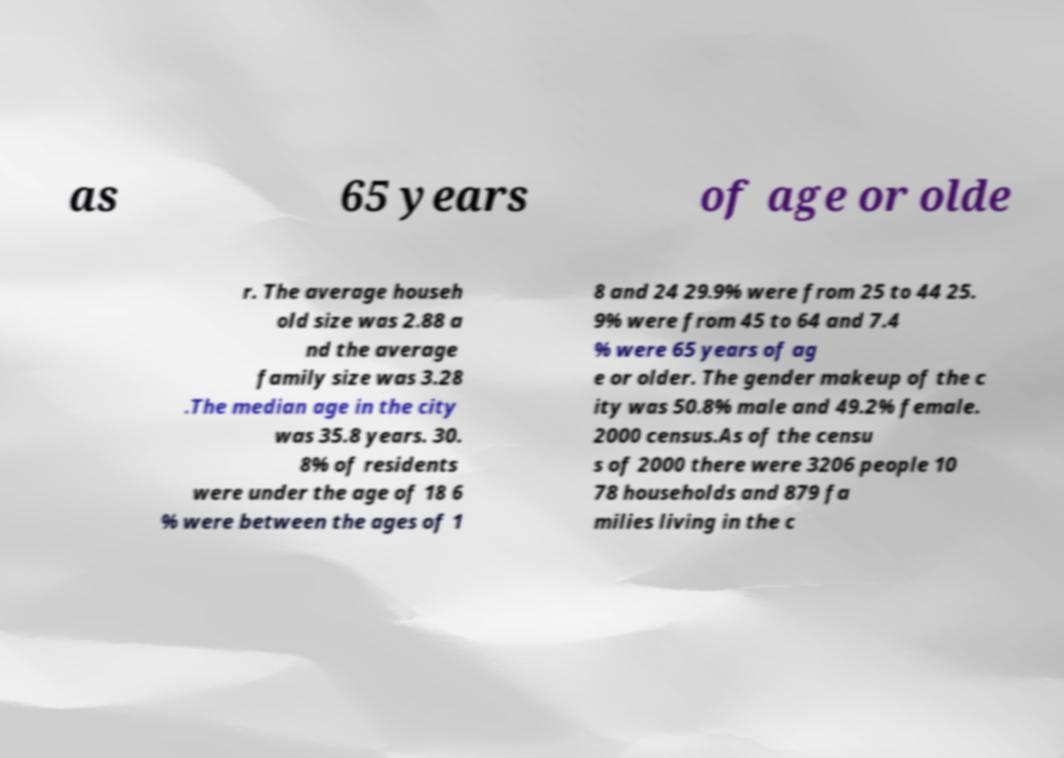Can you read and provide the text displayed in the image?This photo seems to have some interesting text. Can you extract and type it out for me? as 65 years of age or olde r. The average househ old size was 2.88 a nd the average family size was 3.28 .The median age in the city was 35.8 years. 30. 8% of residents were under the age of 18 6 % were between the ages of 1 8 and 24 29.9% were from 25 to 44 25. 9% were from 45 to 64 and 7.4 % were 65 years of ag e or older. The gender makeup of the c ity was 50.8% male and 49.2% female. 2000 census.As of the censu s of 2000 there were 3206 people 10 78 households and 879 fa milies living in the c 